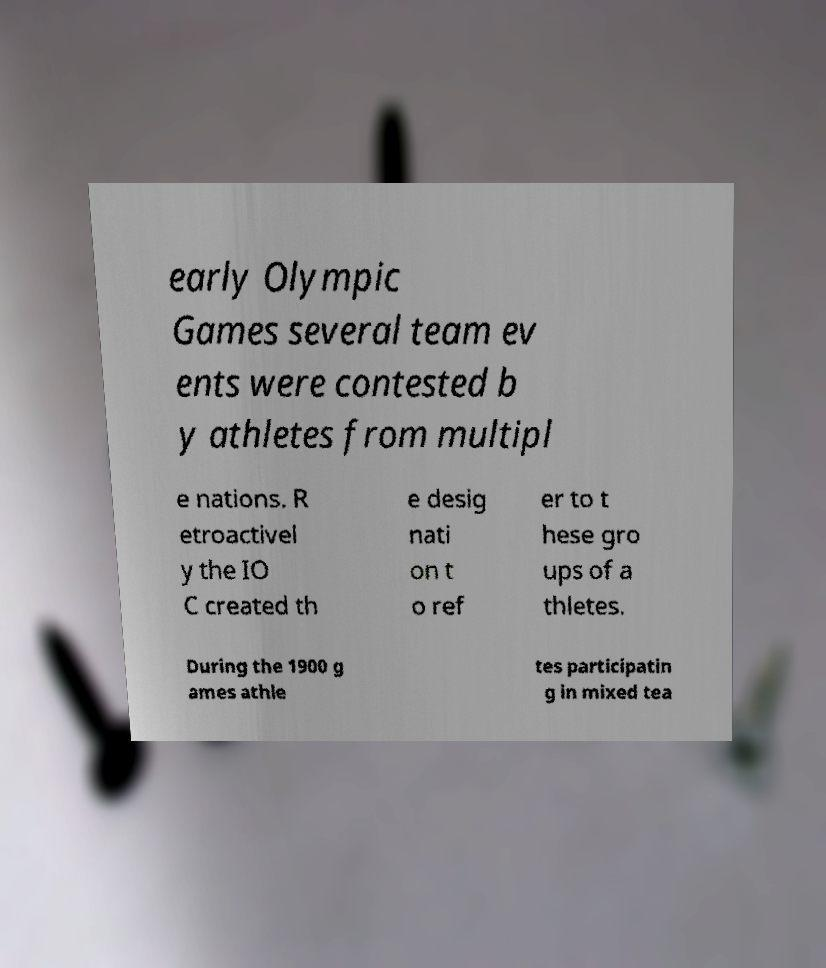Please read and relay the text visible in this image. What does it say? early Olympic Games several team ev ents were contested b y athletes from multipl e nations. R etroactivel y the IO C created th e desig nati on t o ref er to t hese gro ups of a thletes. During the 1900 g ames athle tes participatin g in mixed tea 